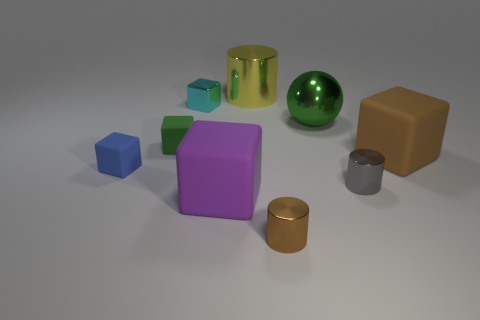The large rubber block to the left of the large yellow cylinder is what color?
Your response must be concise. Purple. Is the number of purple matte things to the right of the tiny gray metal cylinder greater than the number of tiny green matte objects to the left of the big cylinder?
Offer a terse response. No. There is a green thing that is right of the shiny cylinder that is behind the large matte cube on the right side of the large cylinder; what size is it?
Your answer should be compact. Large. Is there another metal block that has the same color as the metal cube?
Your answer should be very brief. No. What number of small brown rubber cubes are there?
Give a very brief answer. 0. There is a tiny block that is in front of the matte object that is on the right side of the tiny cylinder that is to the left of the big shiny ball; what is its material?
Provide a short and direct response. Rubber. Is there a big yellow object made of the same material as the cyan block?
Ensure brevity in your answer.  Yes. Do the large brown object and the tiny brown thing have the same material?
Your response must be concise. No. How many blocks are small metallic objects or big yellow shiny things?
Make the answer very short. 1. The large sphere that is the same material as the large yellow cylinder is what color?
Give a very brief answer. Green. 